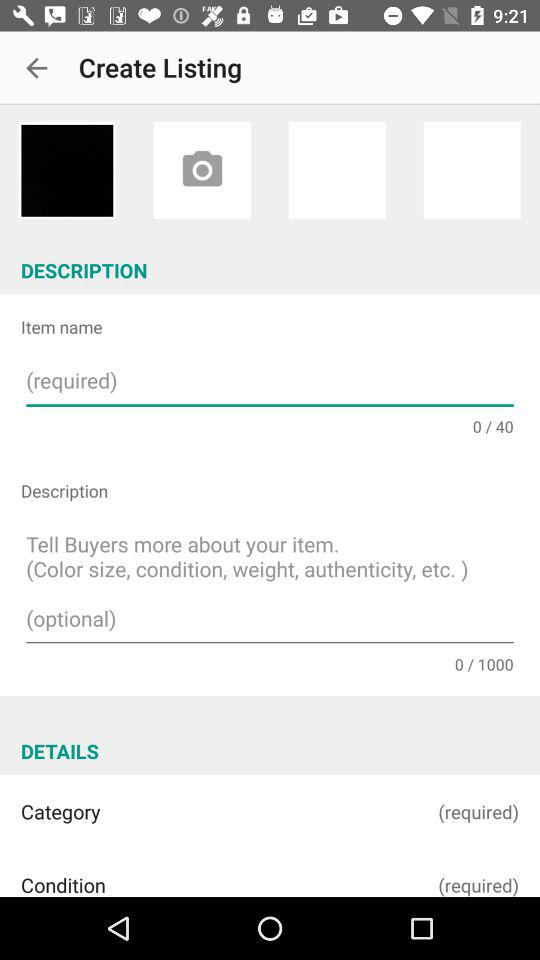What are the features for an item that can be described in a description box?
When the provided information is insufficient, respond with <no answer>. <no answer> 